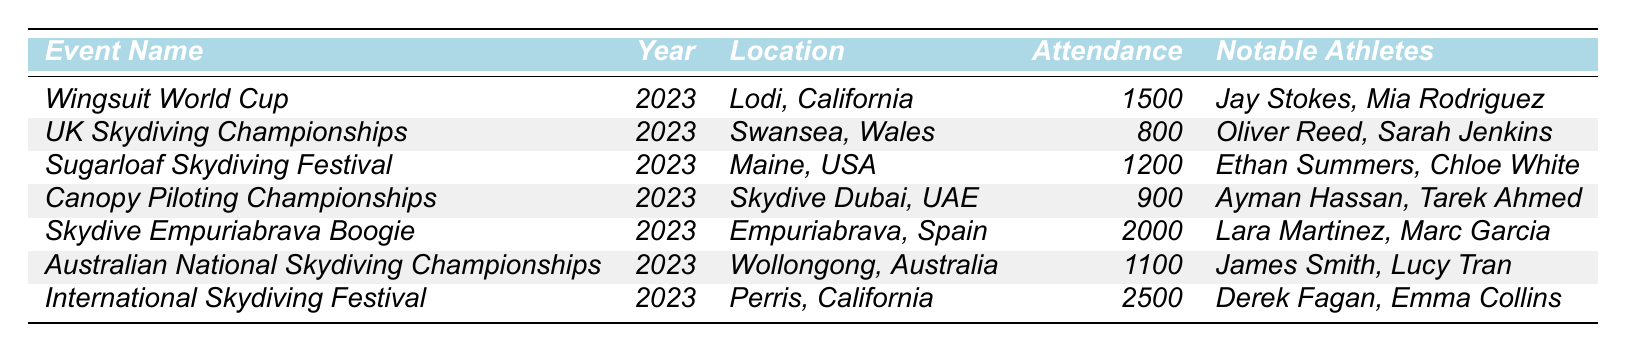What is the total attendance at all events for 2023? To find the total attendance, we add together the attendance figures from each event: 1500 + 800 + 1200 + 900 + 2000 + 1100 + 2500 = 8100.
Answer: 8100 Which event had the highest attendance in 2023? By comparing the attendance figures of each event, we see that the International Skydiving Festival had the highest attendance of 2500.
Answer: International Skydiving Festival How many notable athletes were listed for the UK Skydiving Championships? The UK Skydiving Championships has two notable athletes listed: Oliver Reed and Sarah Jenkins.
Answer: 2 Is there any event that took place in California in 2023? Yes, there are two events listed that took place in California: the Wingsuit World Cup and the International Skydiving Festival.
Answer: Yes What is the average attendance across all events in 2023? First, we calculate the total attendance (8100) and divide it by the number of events (7): 8100 / 7 = approximately 1157.14.
Answer: Approximately 1157.14 Did the Australian National Skydiving Championships have higher attendance than the Canopy Piloting Championships? The Australian National Skydiving Championships had an attendance of 1100, while the Canopy Piloting Championships had an attendance of 900. Since 1100 is greater than 900, the statement is true.
Answer: Yes Which location had the lowest attendance in 2023 and what was that attendance? Looking through the attendances, we see the UK Skydiving Championships had the lowest attendance of 800.
Answer: Swansea, Wales; 800 What percentage of the total attendance does the Skydive Empuriabrava Boogie represent? Attendance for the Skydive Empuriabrava Boogie is 2000. To find its percentage of the total 8100, we calculate (2000/8100) * 100 which equals approximately 24.69%.
Answer: Approximately 24.69% Which two events had notable athletes with the first names starting with 'L'? The Skydive Empuriabrava Boogie lists Lara Martinez and the Australian National Skydiving Championships lists Lucy Tran. Thus, both events fit the criteria.
Answer: Yes, Skydive Empuriabrava Boogie and Australian National Skydiving Championships If you combine the attendance of the Wingsuit World Cup and Sugarloaf Skydiving Festival, how does it compare to the Canopy Piloting Championships? The Wingsuit World Cup has an attendance of 1500 and the Sugarloaf Skydiving Festival has 1200. Combined, they have 1500 + 1200 = 2700. The Canopy Piloting Championships has an attendance of 900. Since 2700 is greater than 900, the comparison shows a significant difference.
Answer: 2700 is greater than 900 